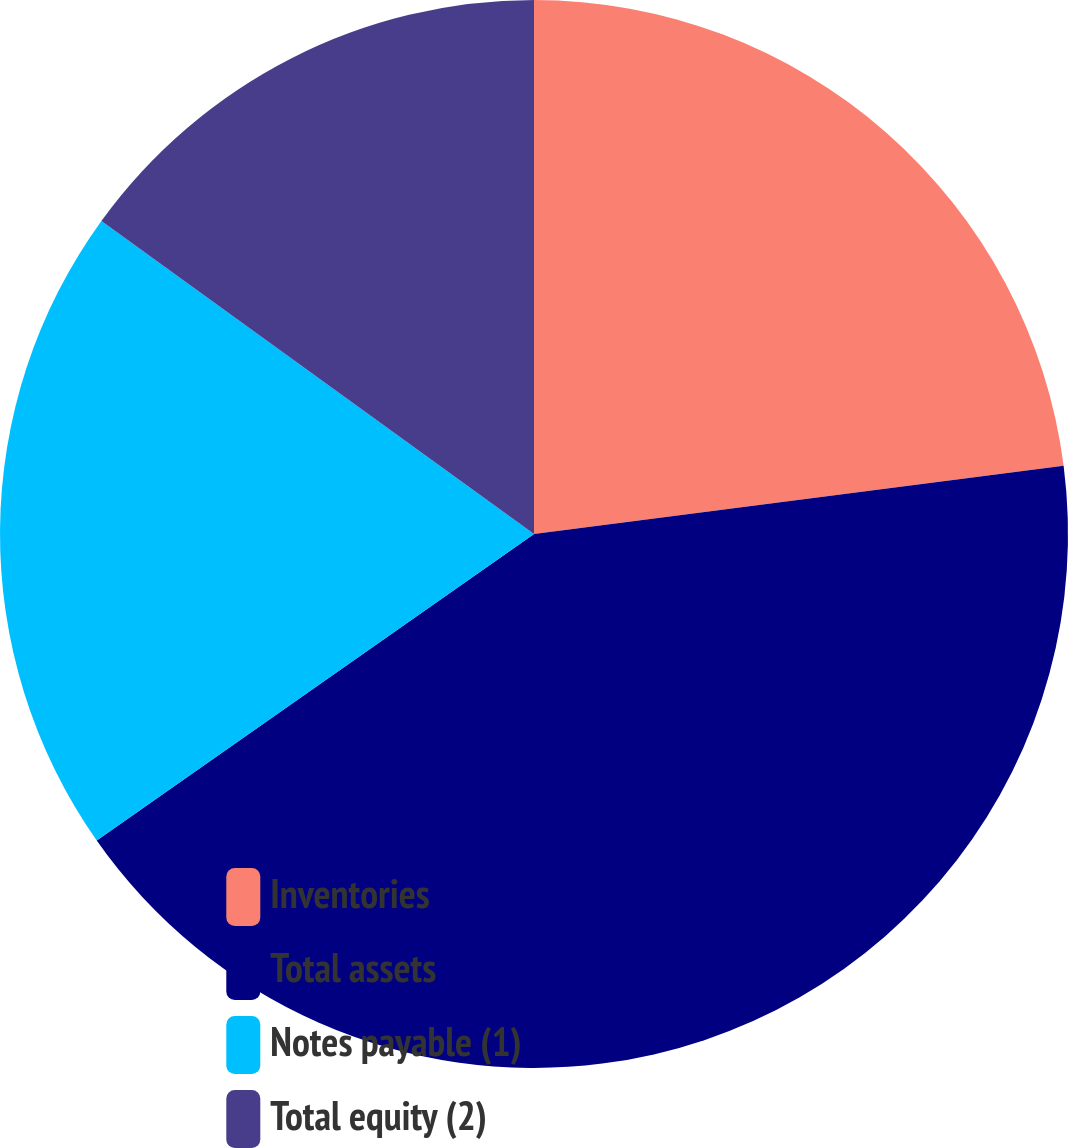<chart> <loc_0><loc_0><loc_500><loc_500><pie_chart><fcel>Inventories<fcel>Total assets<fcel>Notes payable (1)<fcel>Total equity (2)<nl><fcel>22.96%<fcel>42.31%<fcel>19.7%<fcel>15.03%<nl></chart> 